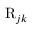<formula> <loc_0><loc_0><loc_500><loc_500>R _ { j k }</formula> 